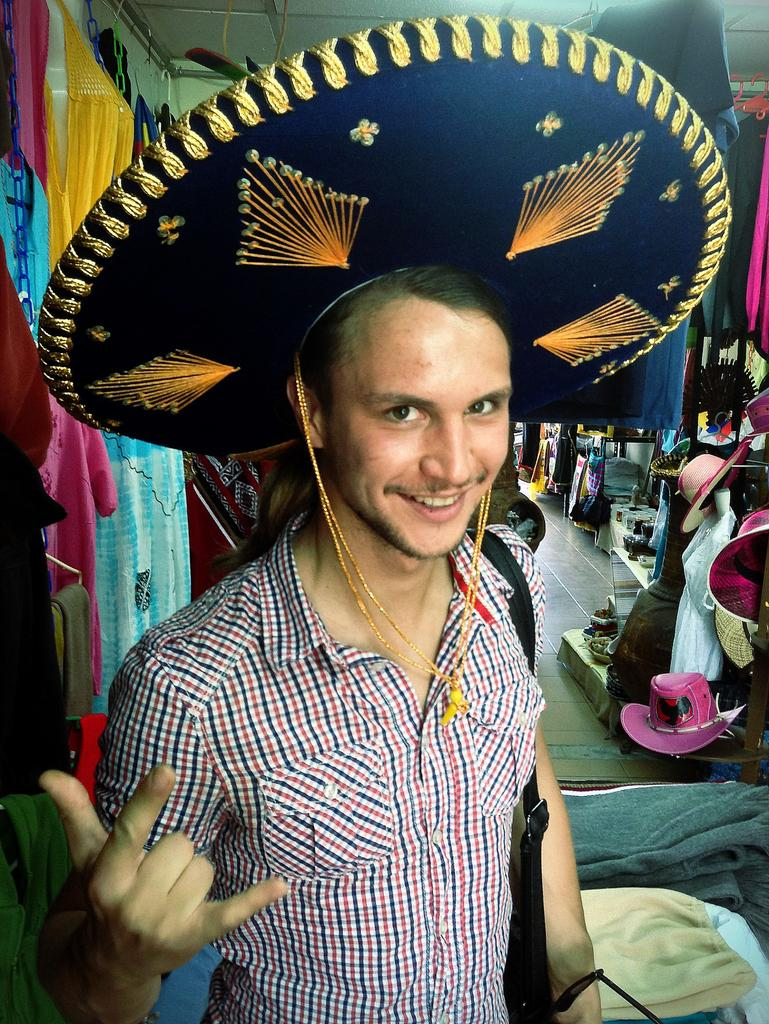Who is present in the image? There is a man in the image. What is the man wearing on his head? The man is wearing a hat. What is the man holding in his hand? The man is holding a pair of glasses (specs) and a bag. What can be seen in the background of the image? There are many hats, clothes, and other unspecified items in the background of the image. What is the weight of the holiday club mentioned in the image? There is no mention of a holiday club or any weight in the image. 